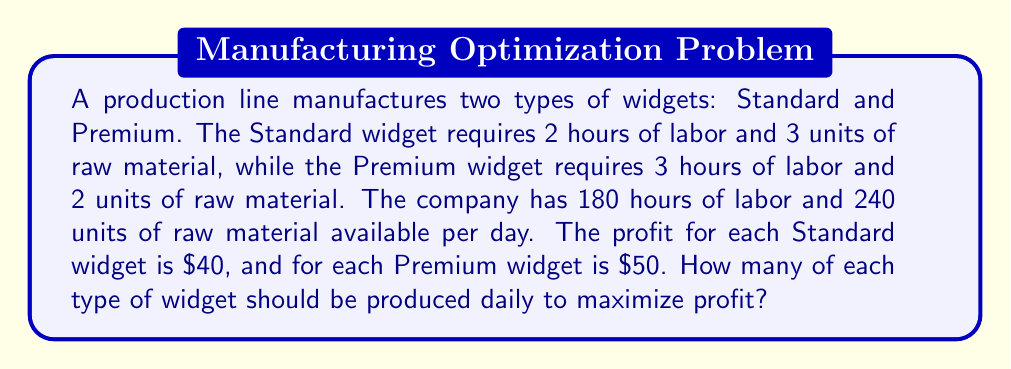What is the answer to this math problem? Let's solve this using linear programming:

1. Define variables:
   Let $x$ = number of Standard widgets
   Let $y$ = number of Premium widgets

2. Objective function (maximize profit):
   $$\text{Maximize } Z = 40x + 50y$$

3. Constraints:
   Labor constraint: $2x + 3y \leq 180$
   Material constraint: $3x + 2y \leq 240$
   Non-negativity: $x \geq 0, y \geq 0$

4. Graph the constraints:
   [asy]
   import graph;
   size(200);
   xaxis("x", 0, 100);
   yaxis("y", 0, 100);
   draw((0,60)--(90,0), blue);
   draw((0,120)--(80,0), red);
   label("Labor", (45,30), blue);
   label("Material", (40,60), red);
   label("Feasible Region", (30,40), green);
   fill((0,0)--(0,60)--(60,40)--(80,0)--cycle, green+opacity(0.2));
   [/asy]

5. Find corner points:
   $(0,0)$, $(0,60)$, $(60,40)$, $(80,0)$

6. Evaluate objective function at corner points:
   $(0,0)$: $Z = 0$
   $(0,60)$: $Z = 3000$
   $(60,40)$: $Z = 4400$
   $(80,0)$: $Z = 3200$

7. The maximum profit occurs at $(60,40)$, which means producing 60 Standard widgets and 40 Premium widgets daily.
Answer: 60 Standard widgets, 40 Premium widgets 